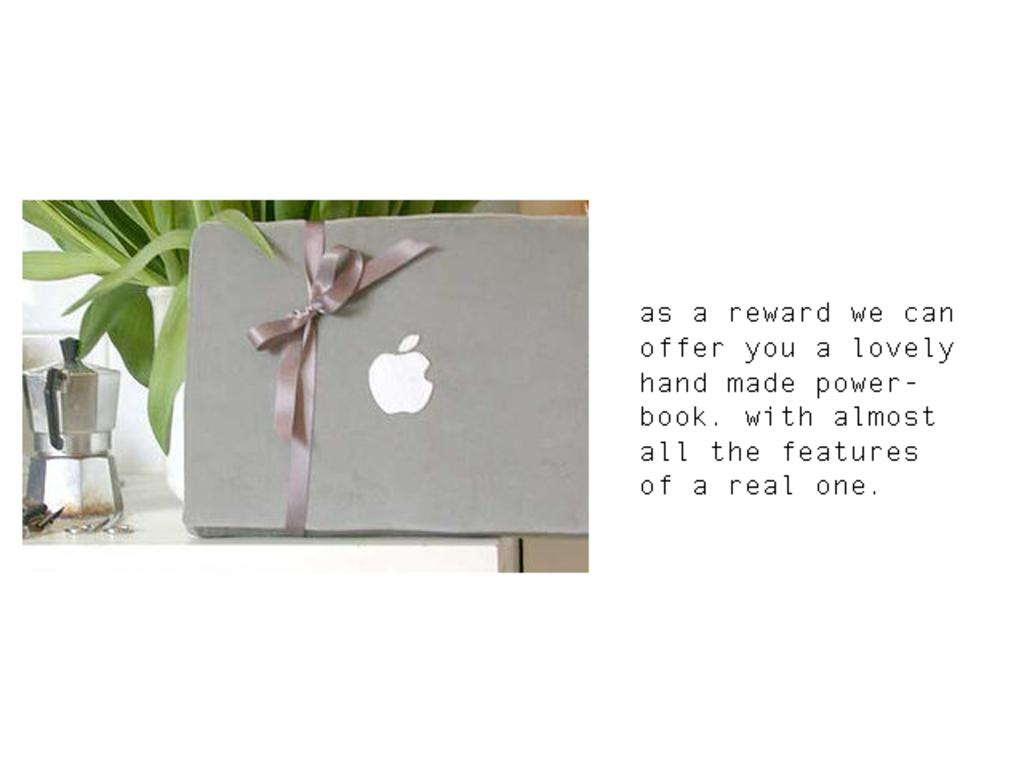<image>
Provide a brief description of the given image. A item with a gift bow sits on a table and the words 'as a reward' are next to it. 